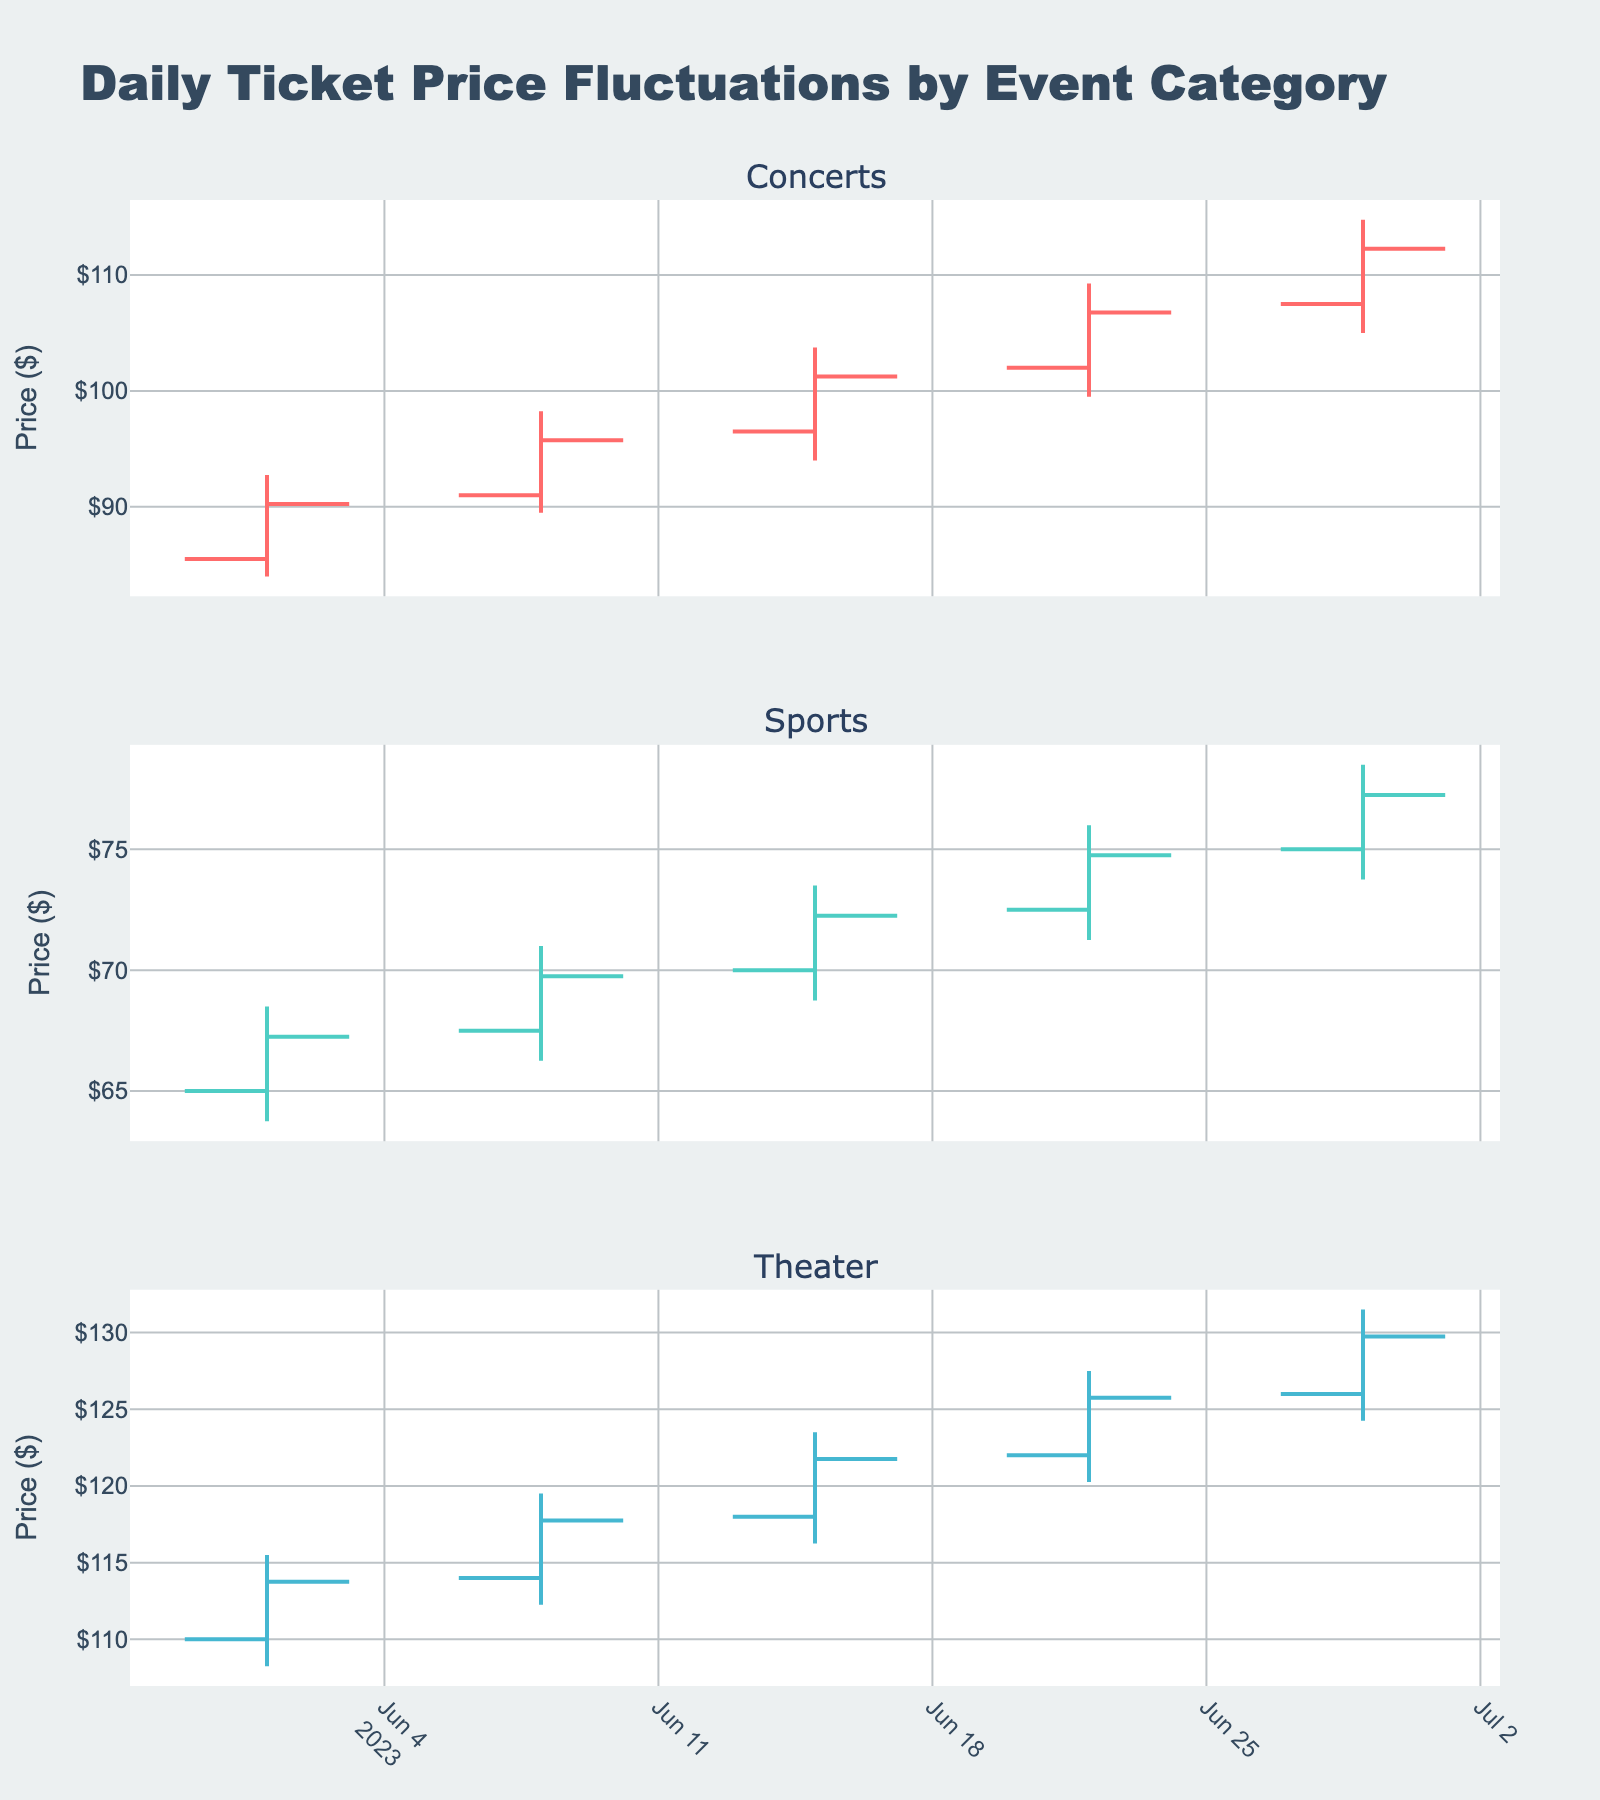What is the title of the figure? The title of the figure is located at the top center of the plot and provides a summary of what the plot represents.
Answer: Daily Ticket Price Fluctuations by Event Category How many categories are presented in the figure? The figure has subplots, each labeled with a category name at the top. There are three subplots, each representing a different category.
Answer: 3 What's the ticket price range for Concerts on June 1st? The OHLC chart for Concerts on June 1st shows the high at $92.75 and the low at $84.00.
Answer: $84.00 to $92.75 Which category saw the highest closing price on June 29th? The closing prices are shown at the end of each bar in the OHLC chart. On June 29th, the highest closing price was in the Theater category at $129.75.
Answer: Theater Which category experienced the greatest price increase between June 1st and June 29th? Calculate the difference between the closing price on June 29th and the opening price on June 1st for each category. Concerts: $112.25 - $85.50 = $26.75. Sports: $77.25 - $65.00 = $12.25. Theater: $129.75 - $110.00 = $19.75.
Answer: Concerts By how much did the closing price of Sports increase from June 1st to June 8th? Subtract the closing price on June 1st from the closing price on June 8th for Sports: $69.75 - $67.25.
Answer: $2.50 Which category had the smallest range between the high and low prices on June 22nd? Calculate the range by subtracting the low price from the high price for each category on June 22nd. Concerts: $109.25 - $99.50 = $9.75. Sports: $76.00 - $71.25 = $4.75. Theater: $127.50 - $120.25 = $7.25.
Answer: Sports How did the closing prices for Theater change over the month? The closing prices for Theater were $113.75 on June 1st, $117.75 on June 8th, $121.75 on June 15th, $125.75 on June 22nd, and $129.75 on June 29th. This shows a steady increase each week.
Answer: Steady increase Which category showed the largest fluctuation on June 29th? Compare the range (high - low) for June 29th across all categories. Concerts: $114.75 - $105.00 = $9.75. Sports: $78.50 - $73.75 = $4.75. Theater: $131.50 - $124.25 = $7.25.
Answer: Concerts 